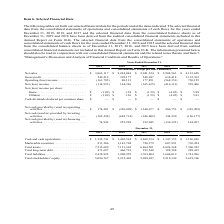According to First Solar's financial document, What was the net income per basic share in 2018? According to the financial document, $1.38. The relevant text states: "6 Net (loss) income per share: Basic . $ (1.09) $ 1.38 $ (1.59) $ (4.05) $ 5.88 Diluted . $ (1.09) $ 1.36 $ (1.59) $ (4.05) $ 5.83 Cash dividends declared..." Also, What was the net cash provided by (used in) operating activities in 2018 and 2019 respectively? The document shows two values: $(326,809) and $174,201 (in thousands). From the document: "h provided by (used in) operating activities. . $ 174,201 $ (326,809) $ 1,340,677 $ 206,753 $ (325,209) Net cash (used in) provided by investing activ..." Also, What was the amount of marketable securities in 2019? According to the financial document, 811,506 (in thousands). The relevant text states: "4 $ 1,347,155 $ 1,126,826 Marketable securities . 811,506 1,143,704 720,379 607,991 703,454 Total assets. . 7,515,689 7,121,362 6,864,501 6,824,368 7,360,392..." Also, can you calculate: What is the change in total shareholders' equity from 2018 to 2019? To answer this question, I need to perform calculations using the financial data. The calculation is: (5,096,767 - 5,212,403) / 5,212,403 , which equals -2.22 (percentage). This is based on the information: "1,606,019 1,741,996 Total stockholders’ equity . 5,096,767 5,212,403 5,098,697 5,218,349 5,618,396 1,741,996 Total stockholders’ equity . 5,096,767 5,212,403 5,098,697 5,218,349 5,618,396..." The key data points involved are: 5,096,767, 5,212,403. Also, can you calculate: What is the difference between Net (loss) income in 2018 and 2019? Based on the calculation: 144,326 - (-114,933) , the result is 259259 (in thousands). This is based on the information: "3 177,851 (568,151) 730,159 Net (loss) income. . (114,933) 144,326 (165,615) (416,112) 593,406 Net (loss) income per share: Basic . $ (1.09) $ 1.38 $ (1.59) (568,151) 730,159 Net (loss) income. . (114..." The key data points involved are: 114,933, 144,326. Also, can you calculate: What was the percentage increase in gross profit from 2018 to 2019? To answer this question, I need to perform calculations using the financial data. The calculation is: (549,212 - 392,177) / 392,177 , which equals 40.04 (percentage). This is based on the information: "24 $ 2,904,563 $ 4,112,650 Gross profit . 549,212 392,177 548,947 638,418 1,132,762 Operating (loss) income. . (161,785) 40,113 177,851 (568,151) 730,159 Net 2,941,324 $ 2,904,563 $ 4,112,650 Gross pr..." The key data points involved are: 392,177, 549,212. 